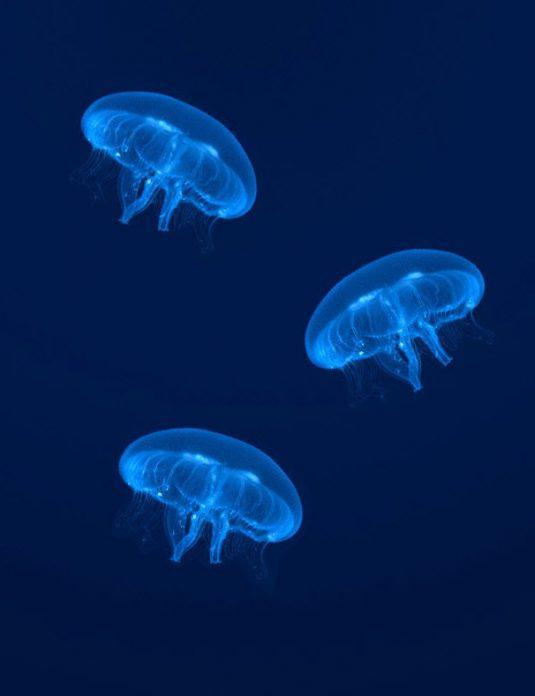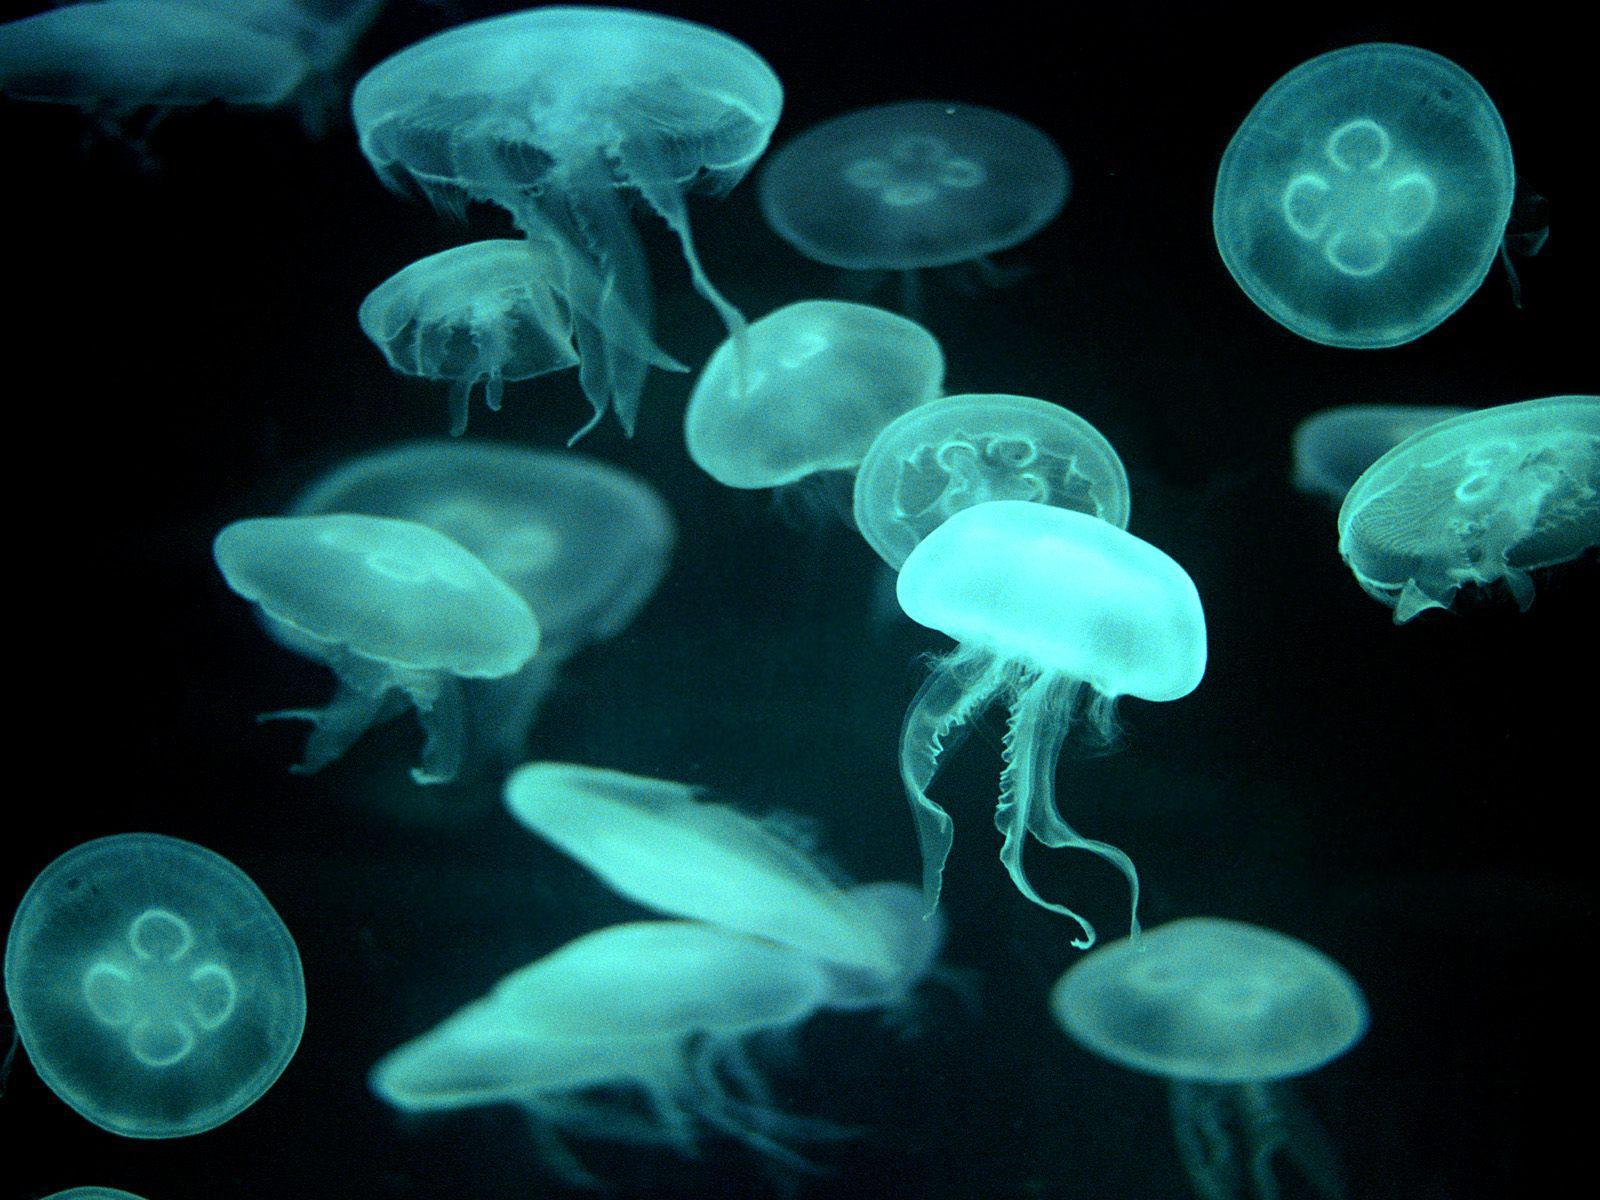The first image is the image on the left, the second image is the image on the right. Given the left and right images, does the statement "The left image shows at least two translucent blue jellyfish with short tentacles and mushroom shapes, and the right image includes a jellyfish with aqua coloring and longer tentacles." hold true? Answer yes or no. Yes. The first image is the image on the left, the second image is the image on the right. Assess this claim about the two images: "The image on the left shows exactly 3 jellyfish.". Correct or not? Answer yes or no. Yes. 